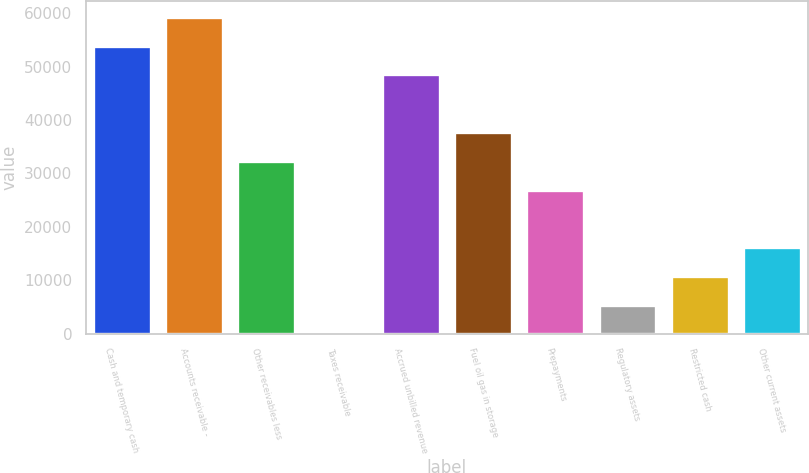Convert chart. <chart><loc_0><loc_0><loc_500><loc_500><bar_chart><fcel>Cash and temporary cash<fcel>Accounts receivable -<fcel>Other receivables less<fcel>Taxes receivable<fcel>Accrued unbilled revenue<fcel>Fuel oil gas in storage<fcel>Prepayments<fcel>Regulatory assets<fcel>Restricted cash<fcel>Other current assets<nl><fcel>53920<fcel>59307.1<fcel>32371.6<fcel>49<fcel>48532.9<fcel>37758.7<fcel>26984.5<fcel>5436.1<fcel>10823.2<fcel>16210.3<nl></chart> 